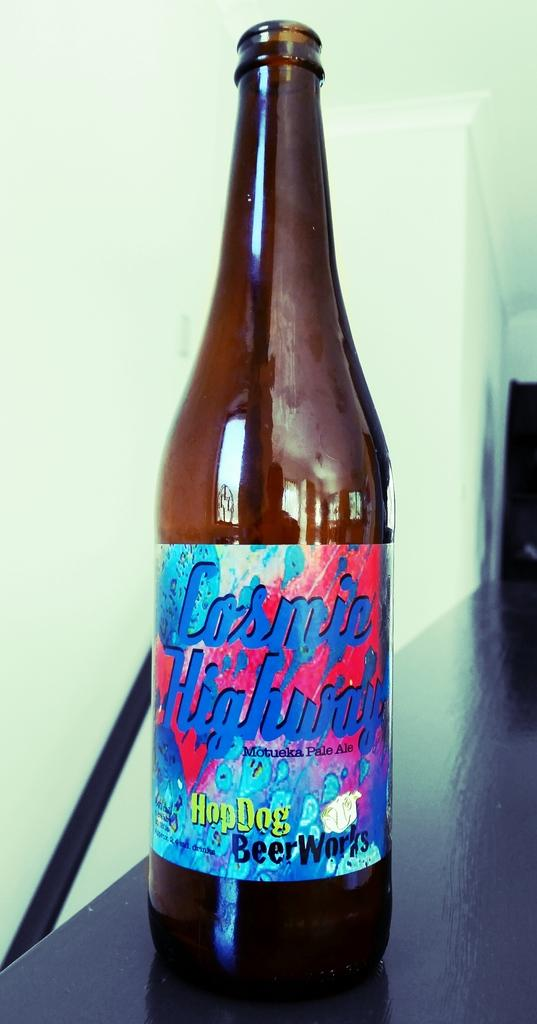<image>
Provide a brief description of the given image. Bottle with a label saying HopDog Beer Works. 